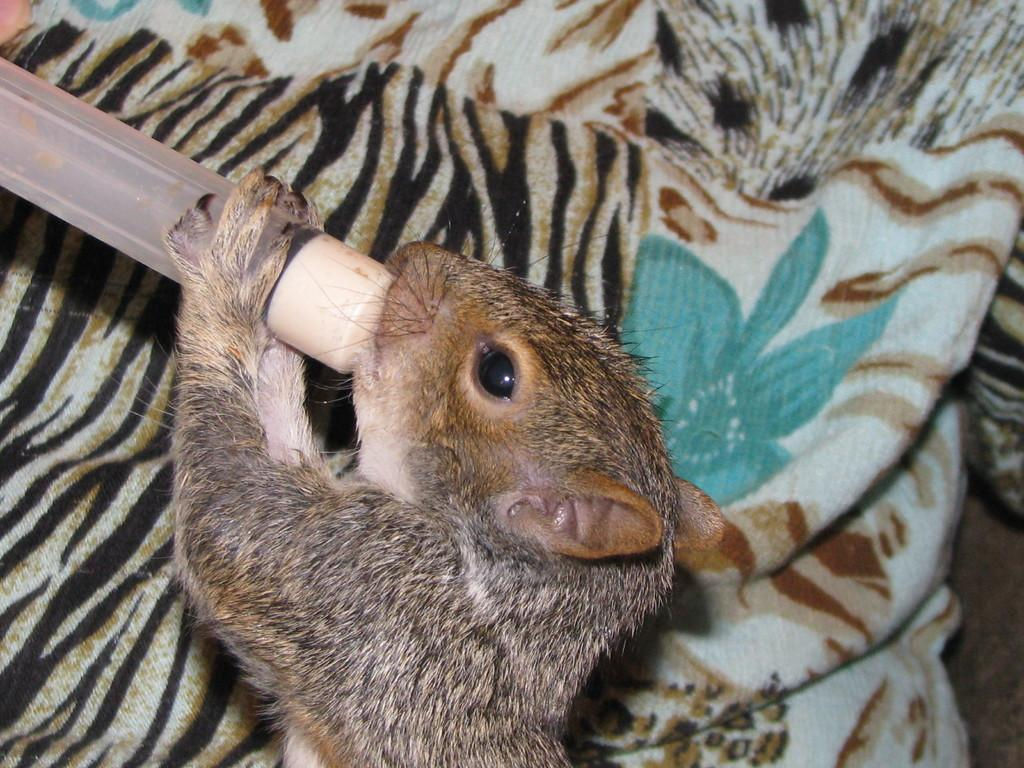What type of creature is present in the image? There is an animal in the image. What is the animal doing in the image? The animal is holding an object. Can you describe the coloring of the animal? The animal has brown and black coloring. What colors can be seen in the background of the image? The background of the image has brown, black, and white colors. What type of cream can be seen on the animal's fur in the image? There is no cream visible on the animal's fur in the image. How many bricks are stacked on the animal's back in the image? There are no bricks present in the image. 